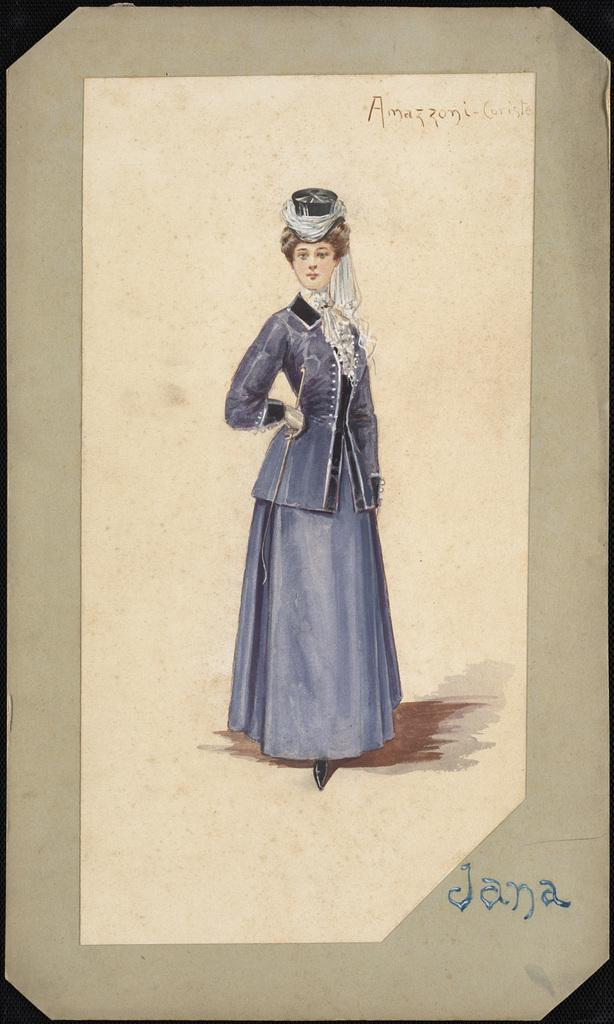What is the main subject of the image? There is a photo in the image. Can you describe the person in the photo? There is a lady standing in the image. What is the lady wearing? The lady is wearing a blue dress. What is the lady's opinion on the star in the image? There is no star present in the image, so it is not possible to determine the lady's opinion on it. 